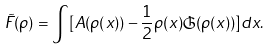Convert formula to latex. <formula><loc_0><loc_0><loc_500><loc_500>\tilde { F } ( \rho ) = \int [ A ( \rho ( x ) ) - \frac { 1 } { 2 } \rho ( x ) \mathfrak { G } ( \rho ( x ) ) ] d x .</formula> 